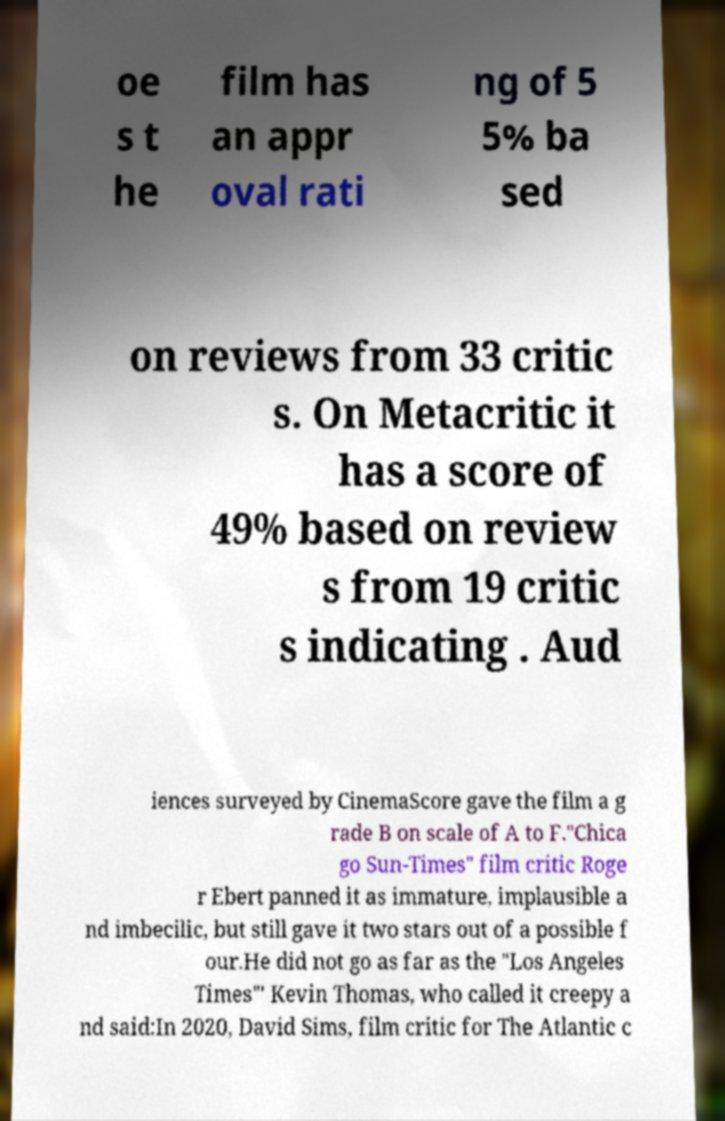For documentation purposes, I need the text within this image transcribed. Could you provide that? oe s t he film has an appr oval rati ng of 5 5% ba sed on reviews from 33 critic s. On Metacritic it has a score of 49% based on review s from 19 critic s indicating . Aud iences surveyed by CinemaScore gave the film a g rade B on scale of A to F."Chica go Sun-Times" film critic Roge r Ebert panned it as immature, implausible a nd imbecilic, but still gave it two stars out of a possible f our.He did not go as far as the "Los Angeles Times"' Kevin Thomas, who called it creepy a nd said:In 2020, David Sims, film critic for The Atlantic c 